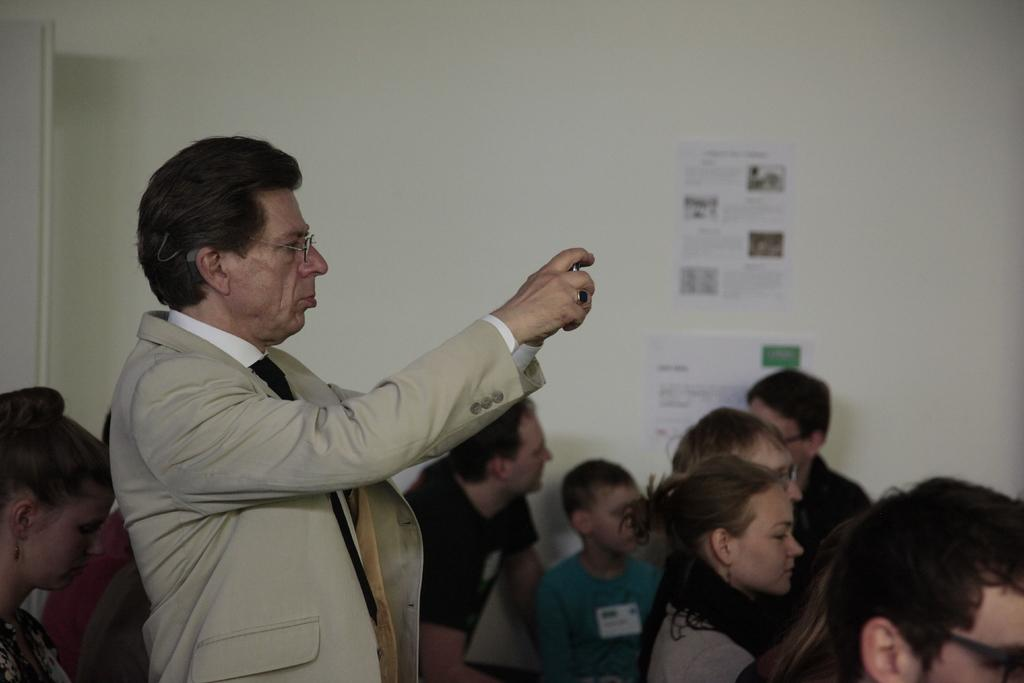How many people are in the image? There are people in the image, but the exact number is not specified. What can be seen in the background of the image? There is a wall in the background of the image. What is on the wall in the image? Posters are present on the wall. What is the person holding in the image? A person is standing and holding an object in the image. How many forks are visible in the image? There is no mention of forks in the image, so we cannot determine their presence or quantity. 